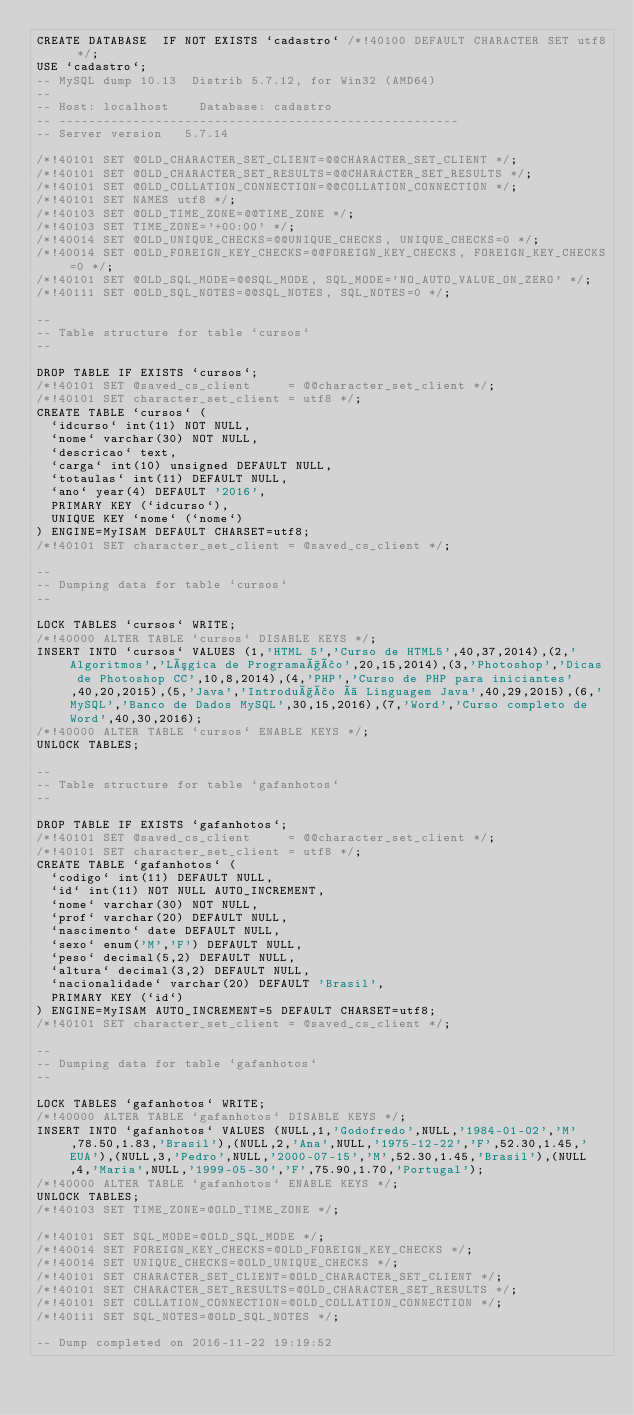<code> <loc_0><loc_0><loc_500><loc_500><_SQL_>CREATE DATABASE  IF NOT EXISTS `cadastro` /*!40100 DEFAULT CHARACTER SET utf8 */;
USE `cadastro`;
-- MySQL dump 10.13  Distrib 5.7.12, for Win32 (AMD64)
--
-- Host: localhost    Database: cadastro
-- ------------------------------------------------------
-- Server version	5.7.14

/*!40101 SET @OLD_CHARACTER_SET_CLIENT=@@CHARACTER_SET_CLIENT */;
/*!40101 SET @OLD_CHARACTER_SET_RESULTS=@@CHARACTER_SET_RESULTS */;
/*!40101 SET @OLD_COLLATION_CONNECTION=@@COLLATION_CONNECTION */;
/*!40101 SET NAMES utf8 */;
/*!40103 SET @OLD_TIME_ZONE=@@TIME_ZONE */;
/*!40103 SET TIME_ZONE='+00:00' */;
/*!40014 SET @OLD_UNIQUE_CHECKS=@@UNIQUE_CHECKS, UNIQUE_CHECKS=0 */;
/*!40014 SET @OLD_FOREIGN_KEY_CHECKS=@@FOREIGN_KEY_CHECKS, FOREIGN_KEY_CHECKS=0 */;
/*!40101 SET @OLD_SQL_MODE=@@SQL_MODE, SQL_MODE='NO_AUTO_VALUE_ON_ZERO' */;
/*!40111 SET @OLD_SQL_NOTES=@@SQL_NOTES, SQL_NOTES=0 */;

--
-- Table structure for table `cursos`
--

DROP TABLE IF EXISTS `cursos`;
/*!40101 SET @saved_cs_client     = @@character_set_client */;
/*!40101 SET character_set_client = utf8 */;
CREATE TABLE `cursos` (
  `idcurso` int(11) NOT NULL,
  `nome` varchar(30) NOT NULL,
  `descricao` text,
  `carga` int(10) unsigned DEFAULT NULL,
  `totaulas` int(11) DEFAULT NULL,
  `ano` year(4) DEFAULT '2016',
  PRIMARY KEY (`idcurso`),
  UNIQUE KEY `nome` (`nome`)
) ENGINE=MyISAM DEFAULT CHARSET=utf8;
/*!40101 SET character_set_client = @saved_cs_client */;

--
-- Dumping data for table `cursos`
--

LOCK TABLES `cursos` WRITE;
/*!40000 ALTER TABLE `cursos` DISABLE KEYS */;
INSERT INTO `cursos` VALUES (1,'HTML 5','Curso de HTML5',40,37,2014),(2,'Algoritmos','Lógica de Programação',20,15,2014),(3,'Photoshop','Dicas de Photoshop CC',10,8,2014),(4,'PHP','Curso de PHP para iniciantes',40,20,2015),(5,'Java','Introdução à Linguagem Java',40,29,2015),(6,'MySQL','Banco de Dados MySQL',30,15,2016),(7,'Word','Curso completo de Word',40,30,2016);
/*!40000 ALTER TABLE `cursos` ENABLE KEYS */;
UNLOCK TABLES;

--
-- Table structure for table `gafanhotos`
--

DROP TABLE IF EXISTS `gafanhotos`;
/*!40101 SET @saved_cs_client     = @@character_set_client */;
/*!40101 SET character_set_client = utf8 */;
CREATE TABLE `gafanhotos` (
  `codigo` int(11) DEFAULT NULL,
  `id` int(11) NOT NULL AUTO_INCREMENT,
  `nome` varchar(30) NOT NULL,
  `prof` varchar(20) DEFAULT NULL,
  `nascimento` date DEFAULT NULL,
  `sexo` enum('M','F') DEFAULT NULL,
  `peso` decimal(5,2) DEFAULT NULL,
  `altura` decimal(3,2) DEFAULT NULL,
  `nacionalidade` varchar(20) DEFAULT 'Brasil',
  PRIMARY KEY (`id`)
) ENGINE=MyISAM AUTO_INCREMENT=5 DEFAULT CHARSET=utf8;
/*!40101 SET character_set_client = @saved_cs_client */;

--
-- Dumping data for table `gafanhotos`
--

LOCK TABLES `gafanhotos` WRITE;
/*!40000 ALTER TABLE `gafanhotos` DISABLE KEYS */;
INSERT INTO `gafanhotos` VALUES (NULL,1,'Godofredo',NULL,'1984-01-02','M',78.50,1.83,'Brasil'),(NULL,2,'Ana',NULL,'1975-12-22','F',52.30,1.45,'EUA'),(NULL,3,'Pedro',NULL,'2000-07-15','M',52.30,1.45,'Brasil'),(NULL,4,'Maria',NULL,'1999-05-30','F',75.90,1.70,'Portugal');
/*!40000 ALTER TABLE `gafanhotos` ENABLE KEYS */;
UNLOCK TABLES;
/*!40103 SET TIME_ZONE=@OLD_TIME_ZONE */;

/*!40101 SET SQL_MODE=@OLD_SQL_MODE */;
/*!40014 SET FOREIGN_KEY_CHECKS=@OLD_FOREIGN_KEY_CHECKS */;
/*!40014 SET UNIQUE_CHECKS=@OLD_UNIQUE_CHECKS */;
/*!40101 SET CHARACTER_SET_CLIENT=@OLD_CHARACTER_SET_CLIENT */;
/*!40101 SET CHARACTER_SET_RESULTS=@OLD_CHARACTER_SET_RESULTS */;
/*!40101 SET COLLATION_CONNECTION=@OLD_COLLATION_CONNECTION */;
/*!40111 SET SQL_NOTES=@OLD_SQL_NOTES */;

-- Dump completed on 2016-11-22 19:19:52
</code> 